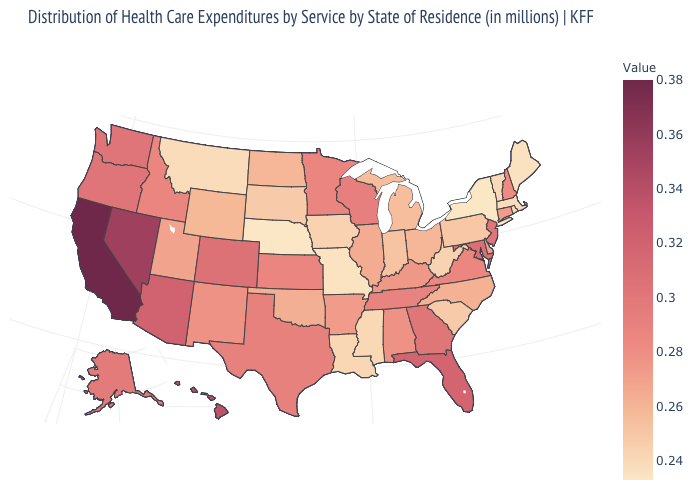Is the legend a continuous bar?
Be succinct. Yes. Among the states that border Maryland , which have the highest value?
Write a very short answer. Virginia. Does Ohio have the highest value in the MidWest?
Quick response, please. No. Does the map have missing data?
Give a very brief answer. No. Does Massachusetts have a lower value than North Carolina?
Quick response, please. Yes. Is the legend a continuous bar?
Keep it brief. Yes. Does Georgia have the highest value in the USA?
Keep it brief. No. Does Connecticut have the lowest value in the Northeast?
Write a very short answer. No. 